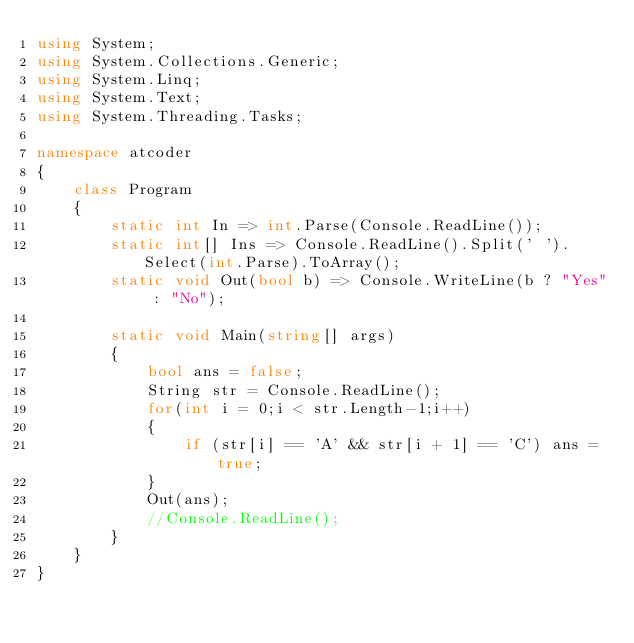Convert code to text. <code><loc_0><loc_0><loc_500><loc_500><_C#_>using System;
using System.Collections.Generic;
using System.Linq;
using System.Text;
using System.Threading.Tasks;

namespace atcoder
{
	class Program
	{
		static int In => int.Parse(Console.ReadLine());
		static int[] Ins => Console.ReadLine().Split(' ').Select(int.Parse).ToArray();
		static void Out(bool b) => Console.WriteLine(b ? "Yes" : "No");

		static void Main(string[] args)
		{
			bool ans = false;
			String str = Console.ReadLine();
			for(int i = 0;i < str.Length-1;i++)
			{
				if (str[i] == 'A' && str[i + 1] == 'C') ans = true;
			}
			Out(ans);
			//Console.ReadLine();
		}
	}
}
</code> 